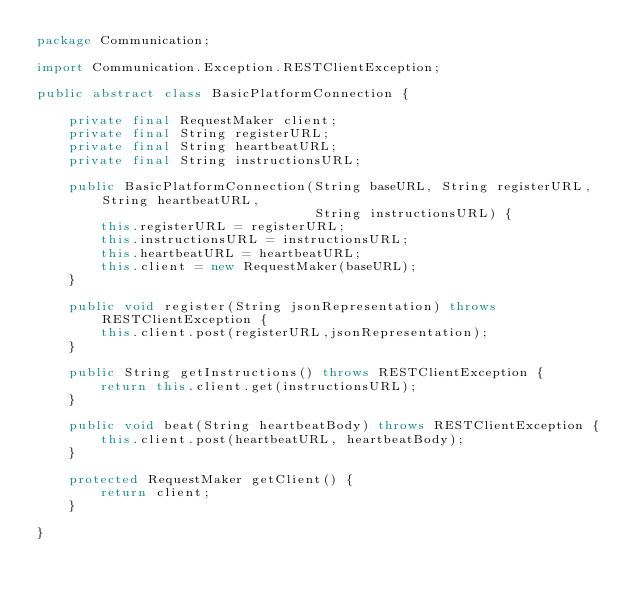Convert code to text. <code><loc_0><loc_0><loc_500><loc_500><_Java_>package Communication;

import Communication.Exception.RESTClientException;

public abstract class BasicPlatformConnection {

    private final RequestMaker client;
    private final String registerURL;
    private final String heartbeatURL;
    private final String instructionsURL;

    public BasicPlatformConnection(String baseURL, String registerURL,String heartbeatURL,
                                   String instructionsURL) {
        this.registerURL = registerURL;
        this.instructionsURL = instructionsURL;
        this.heartbeatURL = heartbeatURL;
        this.client = new RequestMaker(baseURL);
    }

    public void register(String jsonRepresentation) throws RESTClientException {
        this.client.post(registerURL,jsonRepresentation);
    }

    public String getInstructions() throws RESTClientException {
        return this.client.get(instructionsURL);
    }

    public void beat(String heartbeatBody) throws RESTClientException {
        this.client.post(heartbeatURL, heartbeatBody);
    }

    protected RequestMaker getClient() {
        return client;
    }

}
</code> 